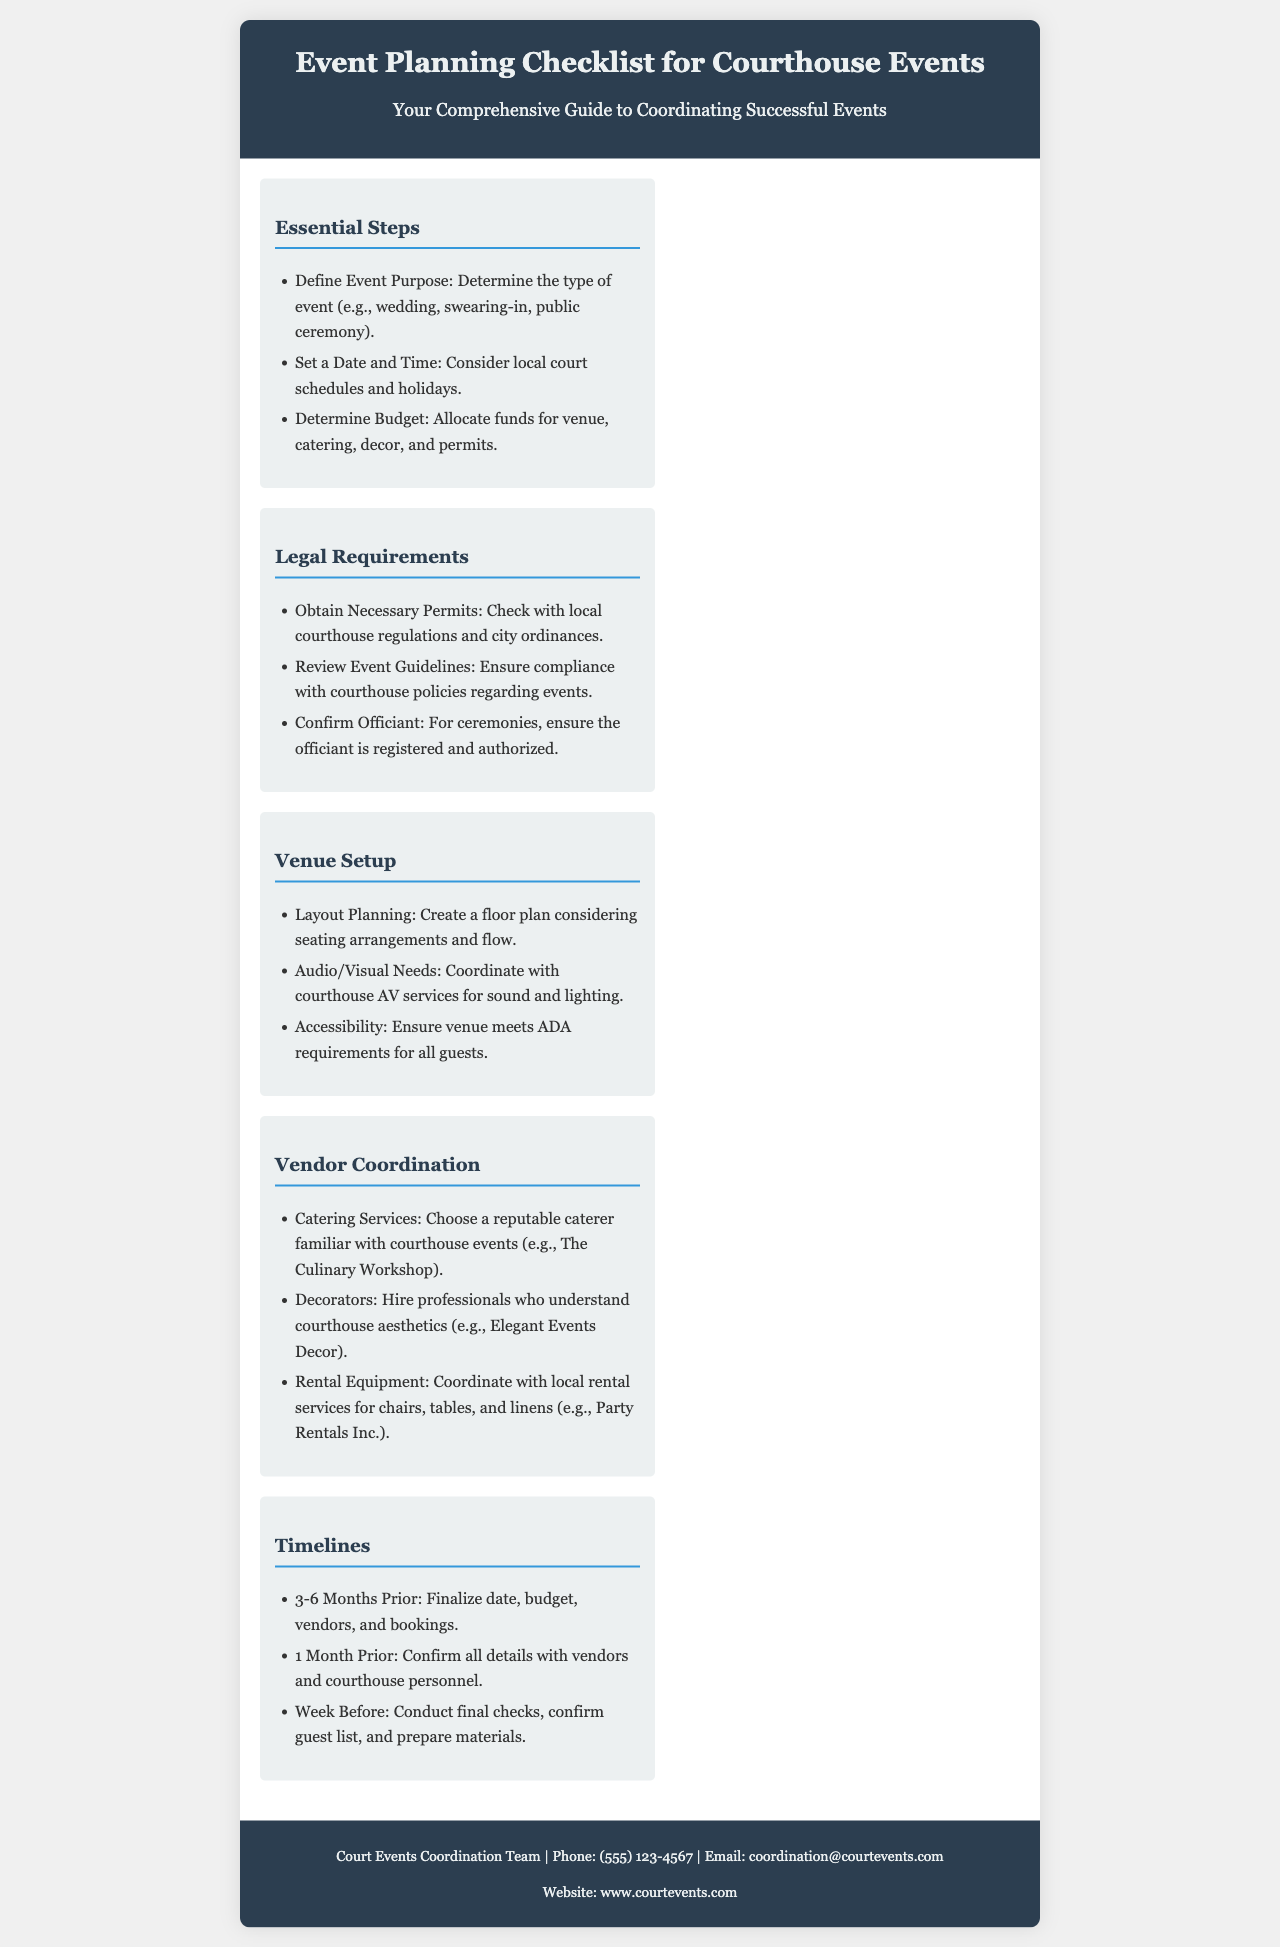What is the title of the brochure? The title appears in the header section of the brochure, stating the focus of the document.
Answer: Event Planning Checklist for Courthouse Events How many months prior should you finalize date, budget, vendors, and bookings? The timeline section indicates when to complete these tasks for effective planning.
Answer: 3-6 Months Prior What should you confirm about the officiant for ceremonies? This is part of the legal requirements and involves ensuring proper registration and authorization.
Answer: Ensure the officiant is registered and authorized Which section discusses seating arrangements and flow? The section that addresses this aspect of event organization is specifically focused on venue planning.
Answer: Venue Setup What is a recommended caterer mentioned in the vendor coordination section? The brochure provides specific names for reputable vendors familiar with courthouse events.
Answer: The Culinary Workshop 